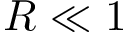Convert formula to latex. <formula><loc_0><loc_0><loc_500><loc_500>R \ll 1</formula> 